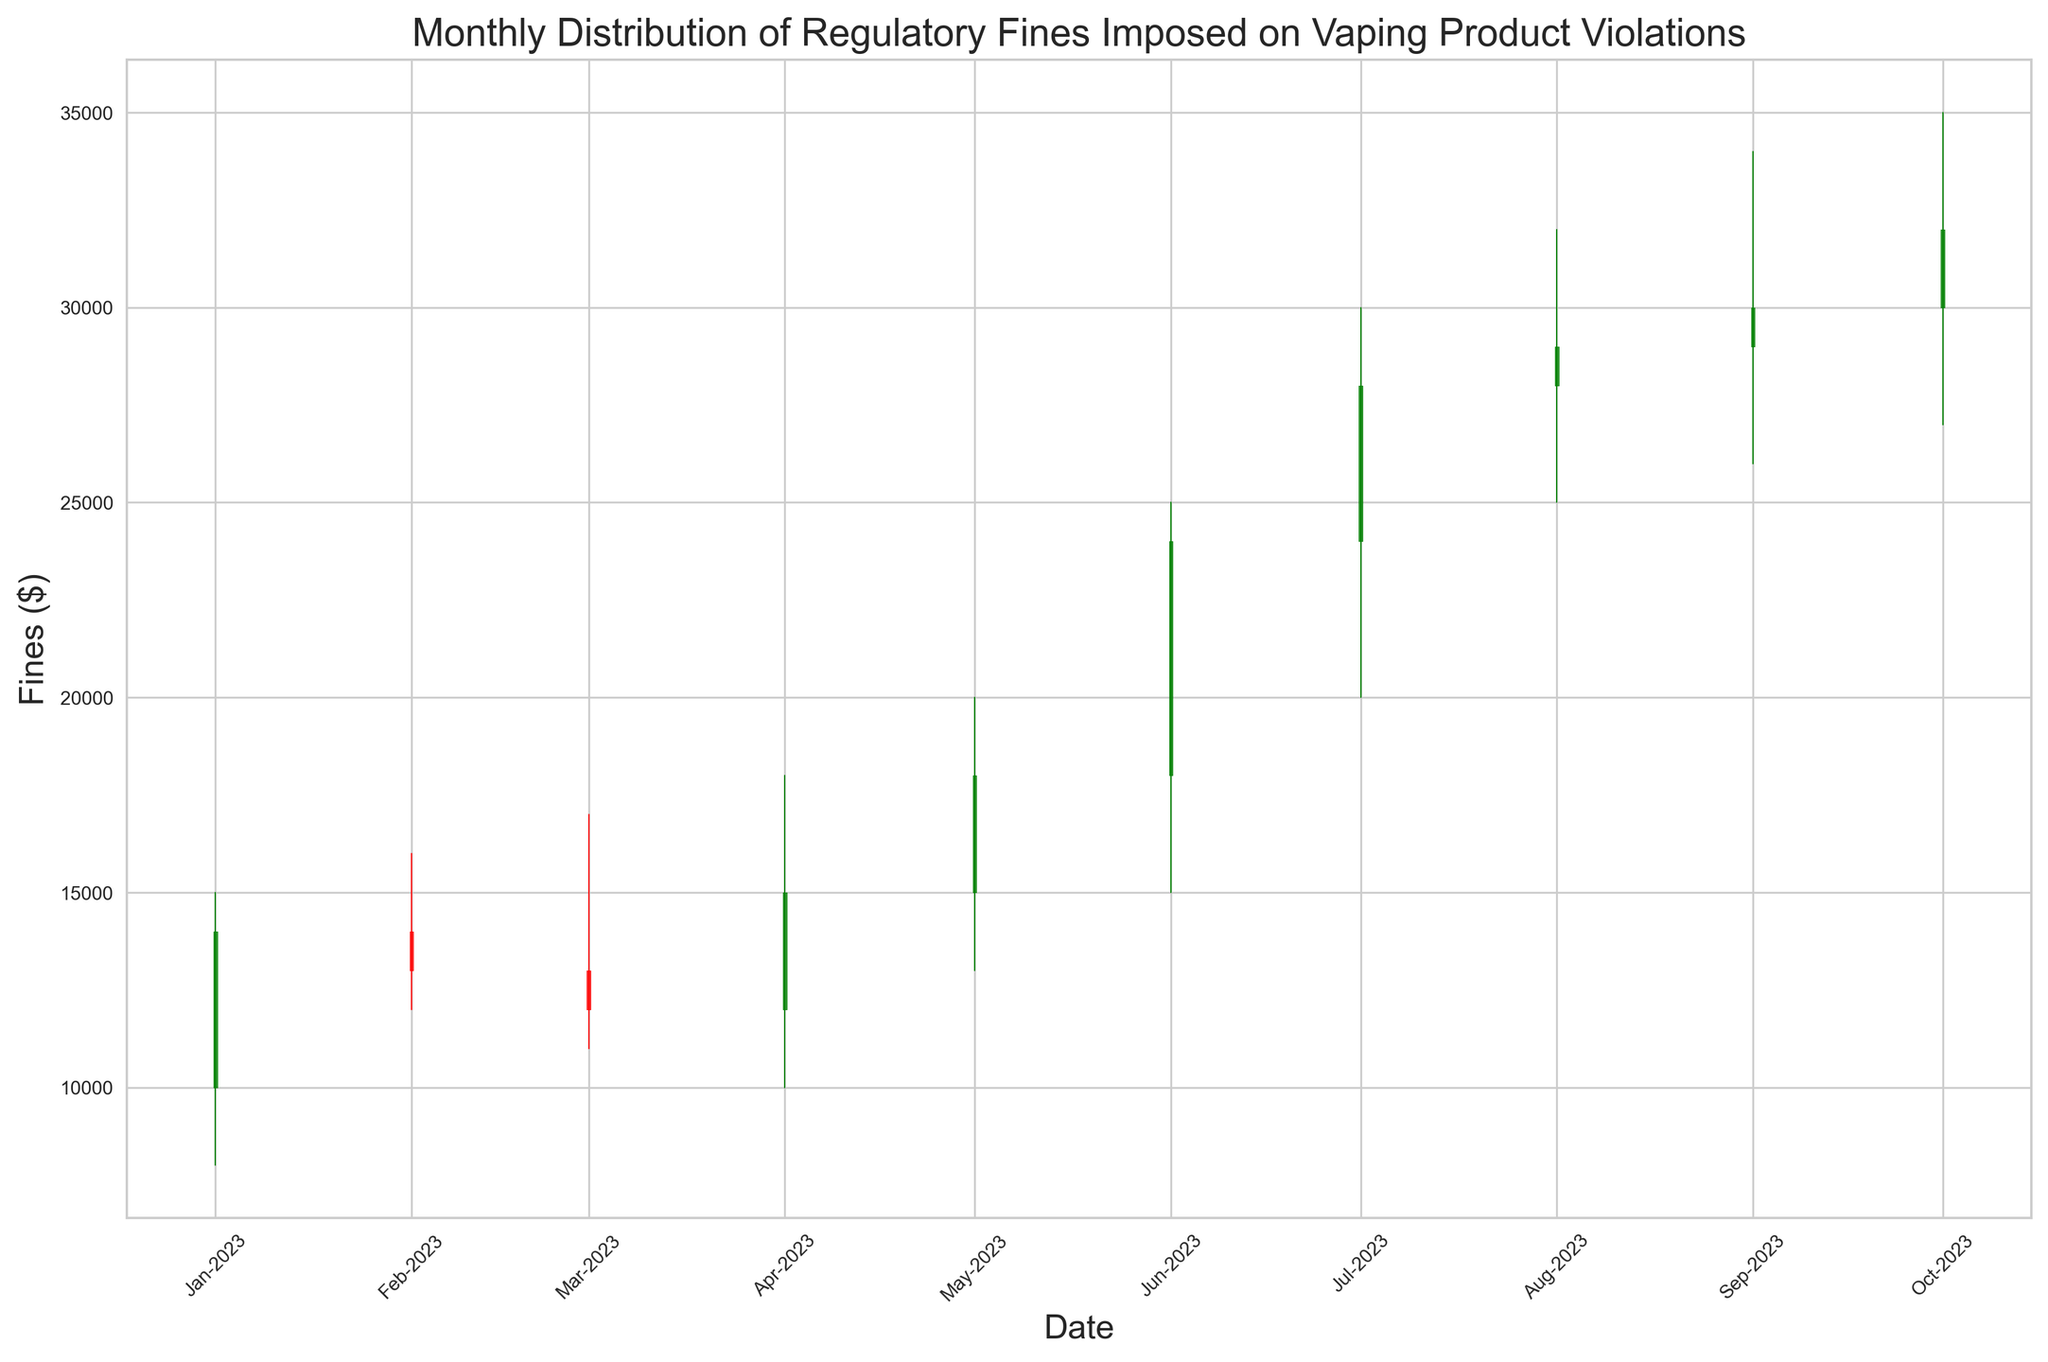What is the highest fine imposed in a single month? The highest fine can be identified from the tallest candlestick, representing the highest point reached. In the month of June 2023, the high was $25,000, the highest visible point on the chart.
Answer: $25,000 How do the fines in August 2023 compare to those in January 2023? In January 2023, the fines are represented by a candlestick ranging from $8,000 (low) to $15,000 (high), closing at $14,000. In August 2023, the low is $25,000, the high is $32,000, closing at $29,000. Both the minimum and maximum fines in August 2023 are substantially higher than those in January 2023.
Answer: August fines are higher than January fines What was the trend in fines from May 2023 to July 2023? To identify the trend, observe the closing prices from May ($18,000) to June ($24,000) and then to July ($28,000). There is a consistent upward trend in the closing fines across these three months.
Answer: Upward trend Which month has the largest difference between the highest and lowest fines? The difference between the highest and lowest fines is the range of the candlestick. For each month, the ranges are: January ($15,000-$8,000 = $7,000), February ($16,000-$12,000 = $4,000), March ($17,000-$11,000 = $6,000), April ($18,000-$10,000 = $8,000), May ($20,000-$13,000 = $7,000), June ($25,000-$15,000 = $10,000), July ($30,000-$20,000 = $10,000), August ($32,000-$25,000 = $7,000), September ($34,000-$26,000 = $8,000), October ($35,000-$27,000 = $8,000). Both June and July have the largest difference, with a range of $10,000.
Answer: June and July What is the average closing fine from January 2023 to July 2023? The closing fines from January 2023 to July 2023 are: $14,000, $13,000, $12,000, $15,000, $18,000, $24,000, $28,000. Sum = $14,000 + $13,000 + $12,000 + $15,000 + $18,000 + $24,000 + $28,000 = $124,000. Average = $124,000 / 7 = $17,714.29.
Answer: $17,714.29 How did the fines change from June 2023 to July 2023? To determine the change, compare the closing fines: $28,000 in July and $24,000 in June. The fine increased by $28,000 - $24,000 = $4,000.
Answer: Increased by $4,000 